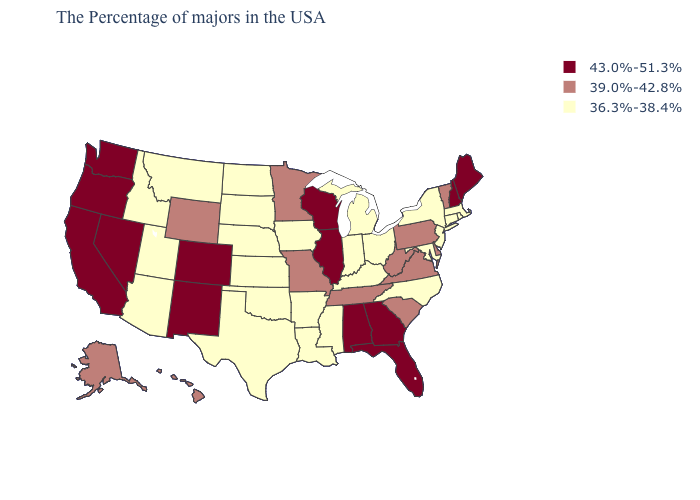Among the states that border Oregon , does Idaho have the lowest value?
Keep it brief. Yes. How many symbols are there in the legend?
Quick response, please. 3. Is the legend a continuous bar?
Quick response, please. No. What is the value of Rhode Island?
Keep it brief. 36.3%-38.4%. Among the states that border Colorado , does Kansas have the lowest value?
Short answer required. Yes. What is the lowest value in the Northeast?
Keep it brief. 36.3%-38.4%. Among the states that border Virginia , which have the lowest value?
Short answer required. Maryland, North Carolina, Kentucky. Name the states that have a value in the range 39.0%-42.8%?
Concise answer only. Vermont, Delaware, Pennsylvania, Virginia, South Carolina, West Virginia, Tennessee, Missouri, Minnesota, Wyoming, Alaska, Hawaii. Among the states that border Colorado , which have the highest value?
Short answer required. New Mexico. Does Nebraska have a lower value than Montana?
Concise answer only. No. What is the value of Oregon?
Concise answer only. 43.0%-51.3%. Name the states that have a value in the range 43.0%-51.3%?
Be succinct. Maine, New Hampshire, Florida, Georgia, Alabama, Wisconsin, Illinois, Colorado, New Mexico, Nevada, California, Washington, Oregon. What is the highest value in the West ?
Answer briefly. 43.0%-51.3%. Does the first symbol in the legend represent the smallest category?
Answer briefly. No. Among the states that border Wyoming , does Colorado have the lowest value?
Quick response, please. No. 